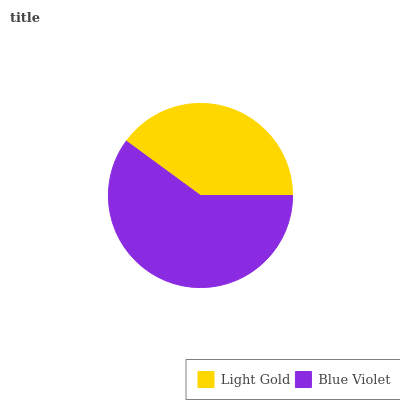Is Light Gold the minimum?
Answer yes or no. Yes. Is Blue Violet the maximum?
Answer yes or no. Yes. Is Blue Violet the minimum?
Answer yes or no. No. Is Blue Violet greater than Light Gold?
Answer yes or no. Yes. Is Light Gold less than Blue Violet?
Answer yes or no. Yes. Is Light Gold greater than Blue Violet?
Answer yes or no. No. Is Blue Violet less than Light Gold?
Answer yes or no. No. Is Blue Violet the high median?
Answer yes or no. Yes. Is Light Gold the low median?
Answer yes or no. Yes. Is Light Gold the high median?
Answer yes or no. No. Is Blue Violet the low median?
Answer yes or no. No. 